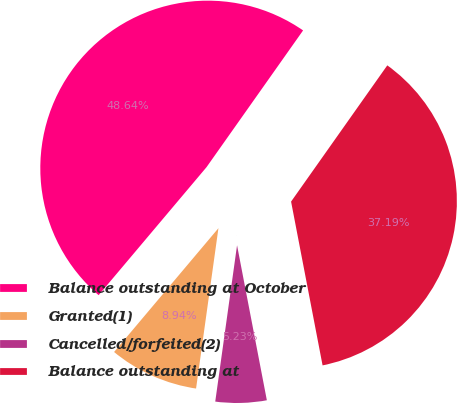Convert chart to OTSL. <chart><loc_0><loc_0><loc_500><loc_500><pie_chart><fcel>Balance outstanding at October<fcel>Granted(1)<fcel>Cancelled/forfeited(2)<fcel>Balance outstanding at<nl><fcel>48.64%<fcel>8.94%<fcel>5.23%<fcel>37.19%<nl></chart> 